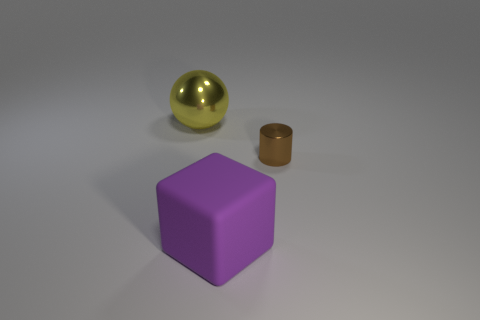There is a rubber object that is the same size as the yellow metal sphere; what is its shape?
Offer a very short reply. Cube. What number of objects are either tiny cyan matte spheres or tiny brown metal objects?
Give a very brief answer. 1. Is there a tiny gray matte block?
Your answer should be compact. No. Is the number of big green shiny cylinders less than the number of big things?
Your answer should be very brief. Yes. Are there any rubber cubes that have the same size as the yellow shiny object?
Your answer should be compact. Yes. How many cubes are either yellow objects or matte objects?
Make the answer very short. 1. The large metal ball has what color?
Offer a terse response. Yellow. Are there more blue cylinders than brown metallic objects?
Ensure brevity in your answer.  No. What number of objects are objects behind the metal cylinder or big matte objects?
Provide a short and direct response. 2. Is the tiny object made of the same material as the cube?
Provide a short and direct response. No. 